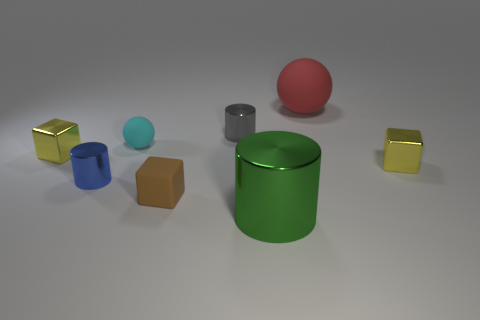Subtract all yellow cylinders. How many yellow blocks are left? 2 Subtract all small gray metallic cylinders. How many cylinders are left? 2 Subtract 1 blocks. How many blocks are left? 2 Add 1 large green shiny cubes. How many objects exist? 9 Subtract all yellow cylinders. Subtract all cyan cubes. How many cylinders are left? 3 Subtract all cubes. How many objects are left? 5 Subtract all tiny gray things. Subtract all green things. How many objects are left? 6 Add 2 tiny cylinders. How many tiny cylinders are left? 4 Add 6 cyan matte spheres. How many cyan matte spheres exist? 7 Subtract 1 gray cylinders. How many objects are left? 7 